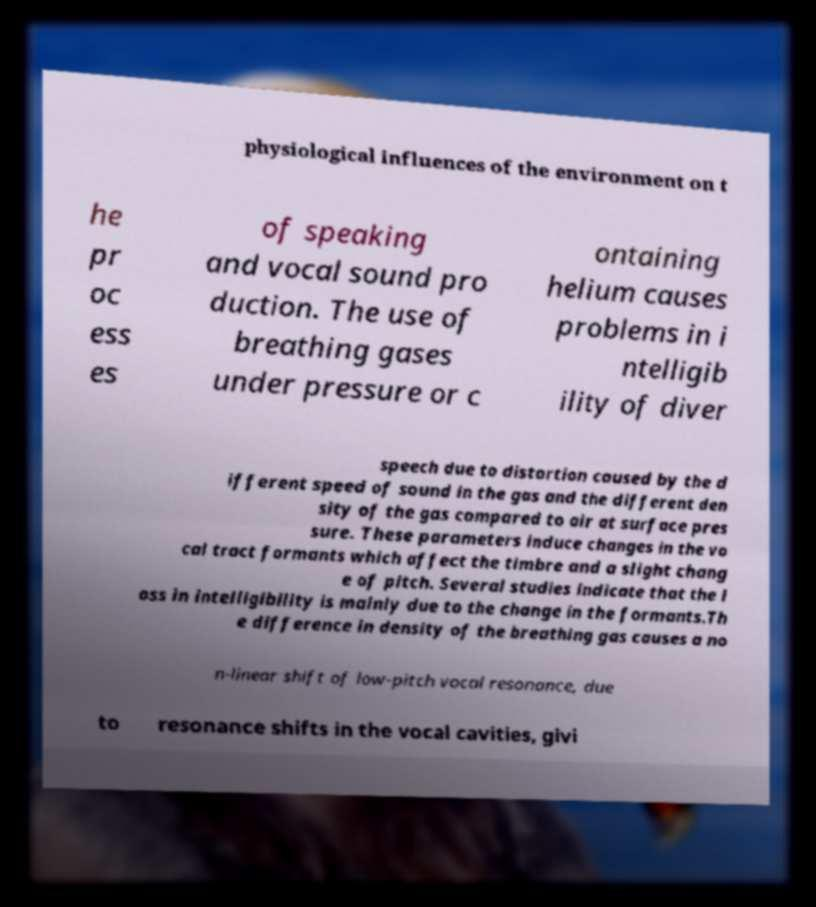What messages or text are displayed in this image? I need them in a readable, typed format. physiological influences of the environment on t he pr oc ess es of speaking and vocal sound pro duction. The use of breathing gases under pressure or c ontaining helium causes problems in i ntelligib ility of diver speech due to distortion caused by the d ifferent speed of sound in the gas and the different den sity of the gas compared to air at surface pres sure. These parameters induce changes in the vo cal tract formants which affect the timbre and a slight chang e of pitch. Several studies indicate that the l oss in intelligibility is mainly due to the change in the formants.Th e difference in density of the breathing gas causes a no n-linear shift of low-pitch vocal resonance, due to resonance shifts in the vocal cavities, givi 